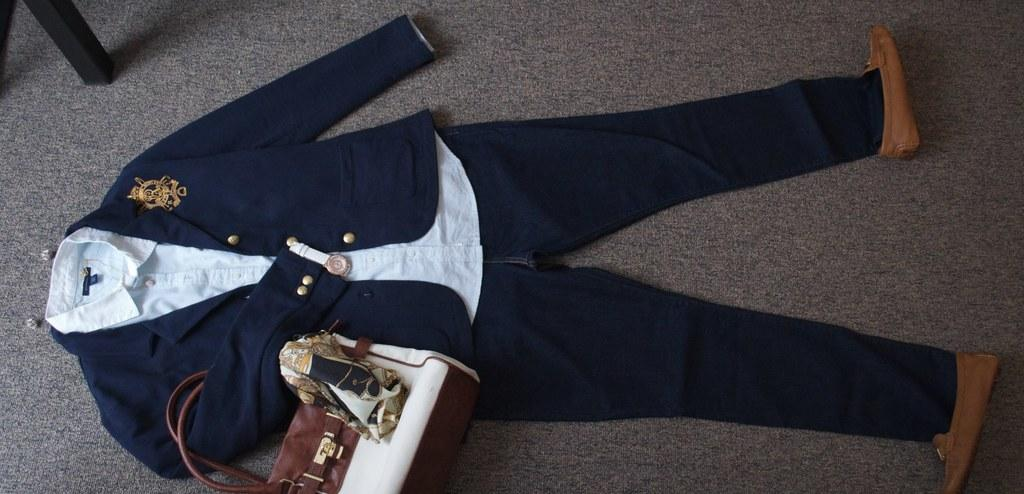What type of clothing item is in the image? There is a dress in the image. What accessory is also visible in the image? There is a handbag in the image. What footwear is present in the image? There are shoes in the image. On what surface are these items placed? The objects are on a surface. What wooden object can be seen in the top left of the image? There is a wooden object in the top left of the image. Is there a kettle visible in the image? No, there is no kettle present in the image. Is there a veil covering the dress in the image? No, there is no veil covering the dress in the image. 